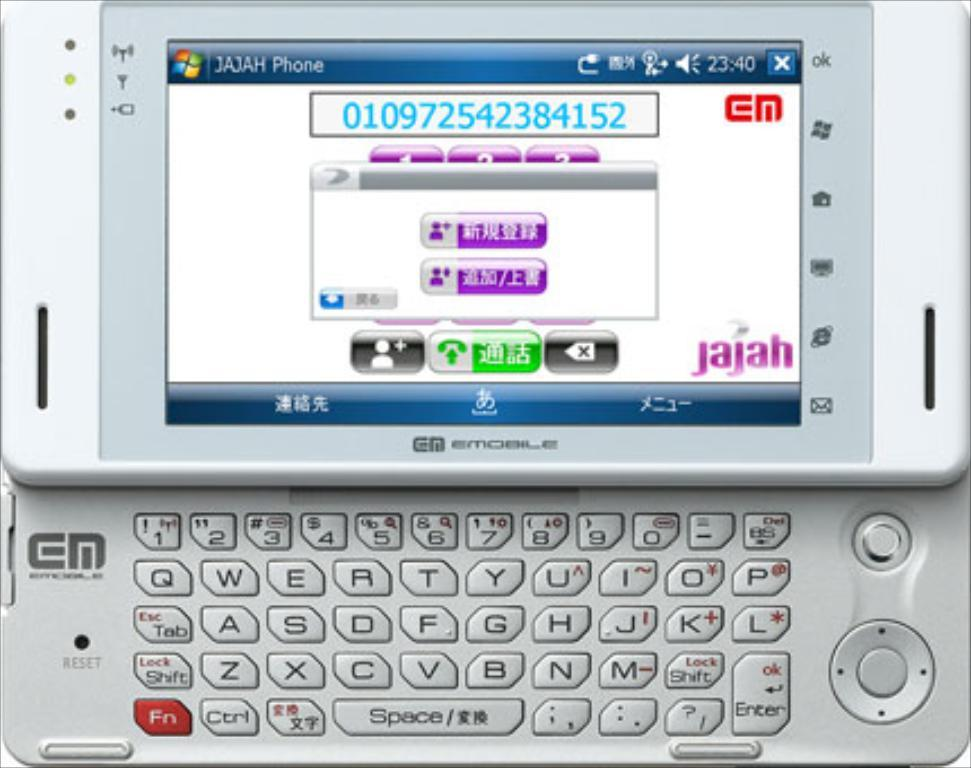<image>
Share a concise interpretation of the image provided. A slider phone that says Jahjah phone on the screen. 